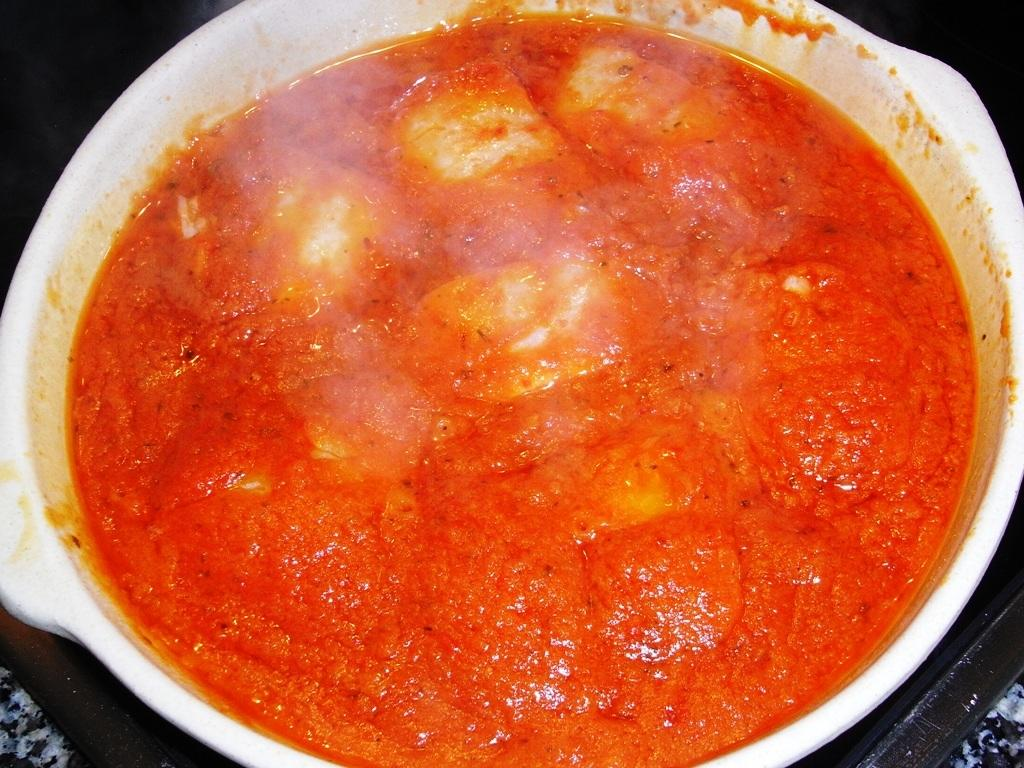What is in the bowl that is visible in the image? There is a bowl in the image. What is the contents of the bowl? The bowl contains curry. Can you describe the color of the curry? The curry is orange in color. Where is the town located in the image? There is no town present in the image; it features a bowl of curry. What type of oven is used to cook the curry in the image? There is no oven present in the image, as it only shows a bowl of curry. 